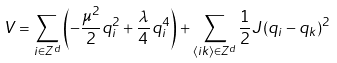<formula> <loc_0><loc_0><loc_500><loc_500>V = \sum _ { i \in Z ^ { d } } \left ( - \frac { \mu ^ { 2 } } { 2 } q _ { i } ^ { 2 } + \frac { \lambda } { 4 \, } q _ { i } ^ { 4 } \right ) + \sum _ { \langle i k \rangle \in Z ^ { d } } \frac { 1 } { 2 } J ( q _ { i } - q _ { k } ) ^ { 2 }</formula> 